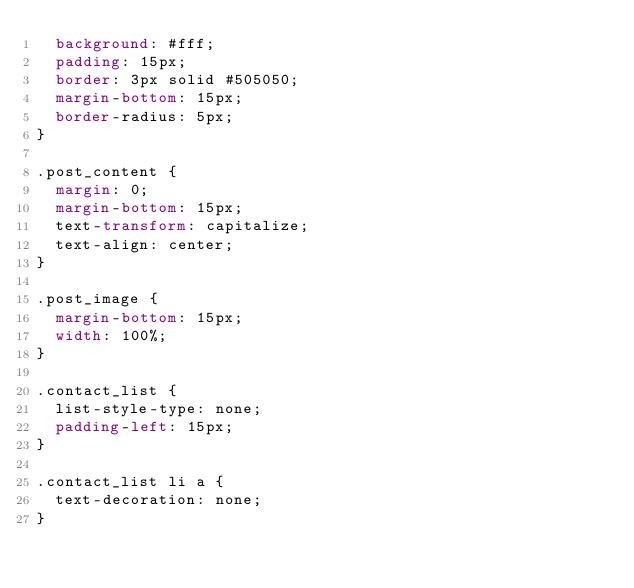Convert code to text. <code><loc_0><loc_0><loc_500><loc_500><_CSS_>  background: #fff;
  padding: 15px;
  border: 3px solid #505050;
  margin-bottom: 15px;
  border-radius: 5px;
}

.post_content {
  margin: 0;
  margin-bottom: 15px;
  text-transform: capitalize;
  text-align: center;
}

.post_image {
  margin-bottom: 15px;
  width: 100%;
}

.contact_list {
  list-style-type: none;
  padding-left: 15px;
}

.contact_list li a {
  text-decoration: none;
}</code> 